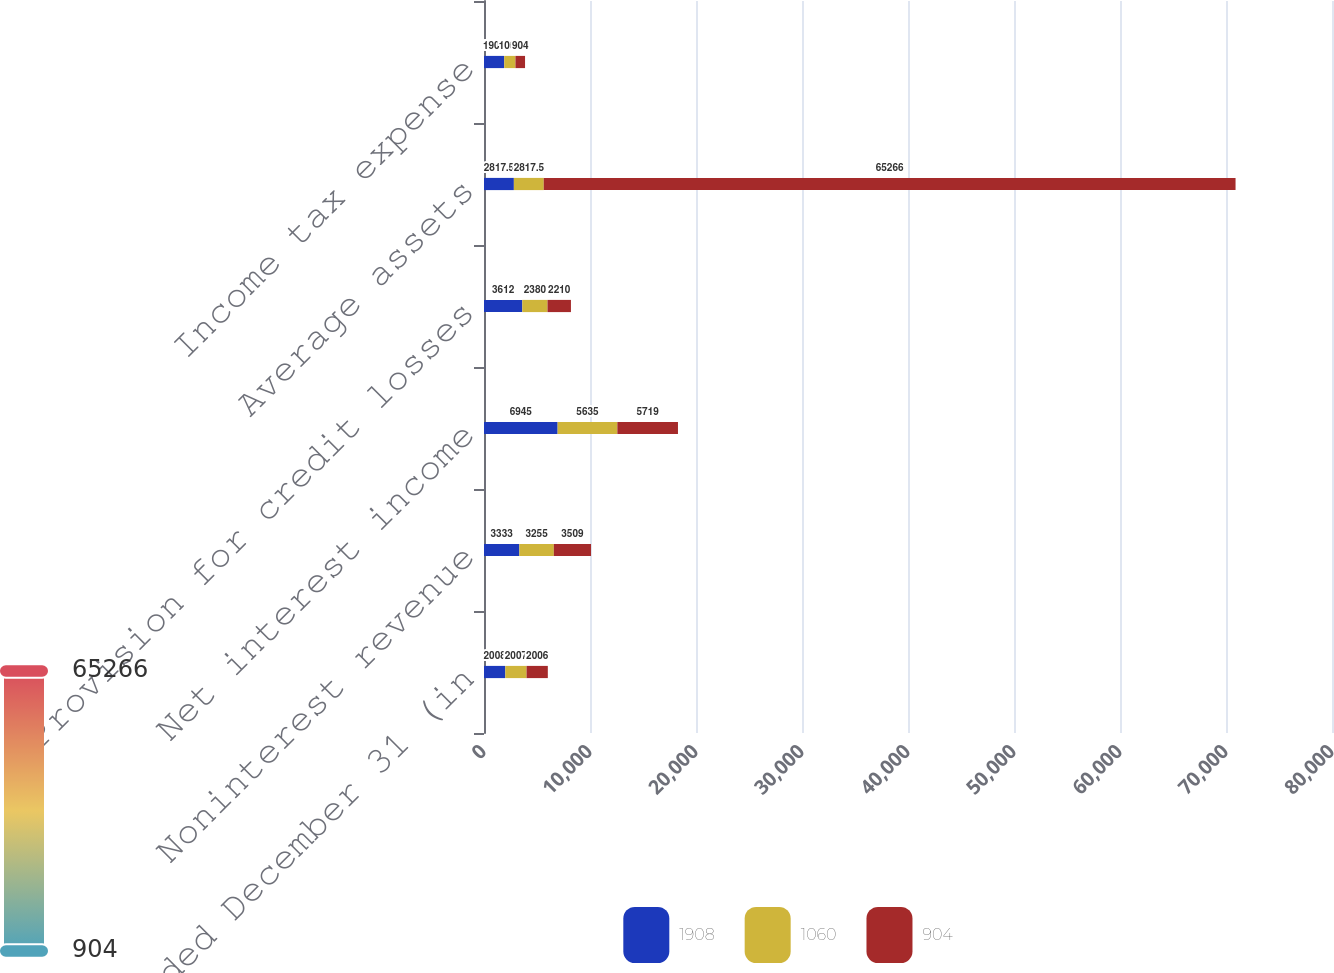Convert chart to OTSL. <chart><loc_0><loc_0><loc_500><loc_500><stacked_bar_chart><ecel><fcel>Year ended December 31 (in<fcel>Noninterest revenue<fcel>Net interest income<fcel>Provision for credit losses<fcel>Average assets<fcel>Income tax expense<nl><fcel>1908<fcel>2008<fcel>3333<fcel>6945<fcel>3612<fcel>2817.5<fcel>1908<nl><fcel>1060<fcel>2007<fcel>3255<fcel>5635<fcel>2380<fcel>2817.5<fcel>1060<nl><fcel>904<fcel>2006<fcel>3509<fcel>5719<fcel>2210<fcel>65266<fcel>904<nl></chart> 